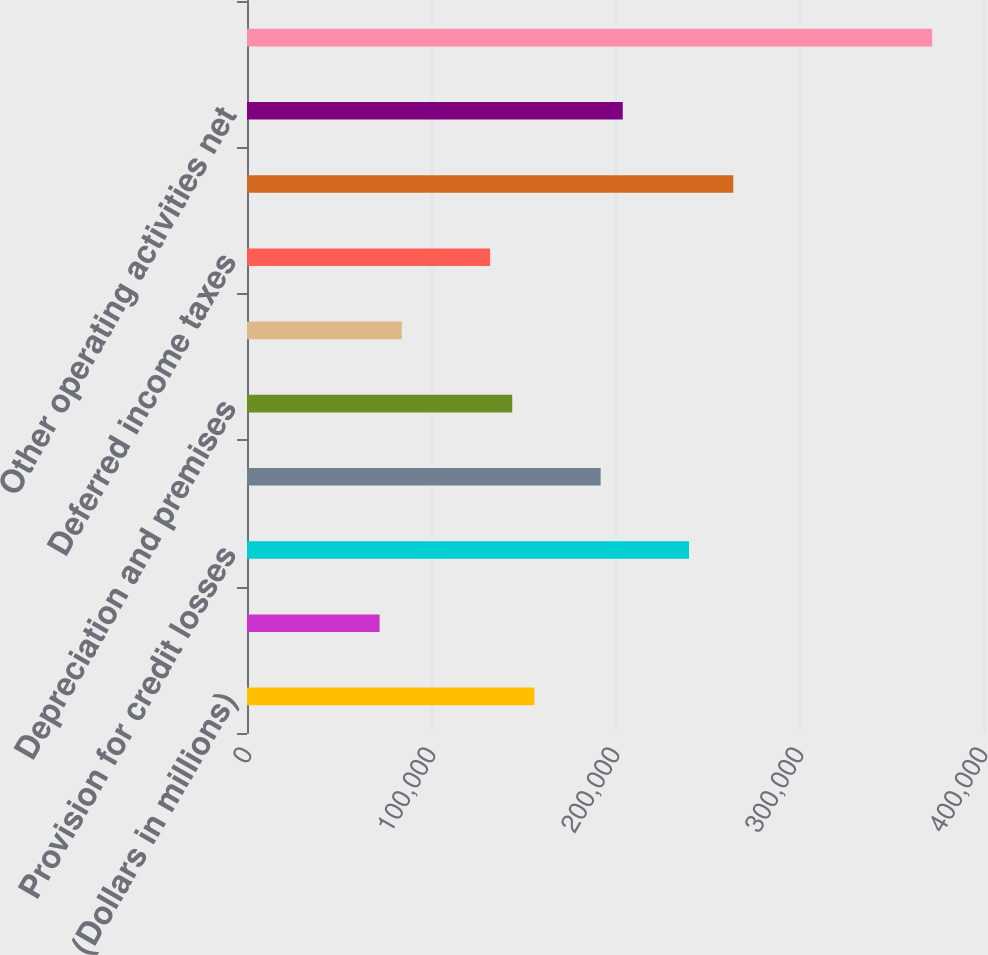Convert chart. <chart><loc_0><loc_0><loc_500><loc_500><bar_chart><fcel>(Dollars in millions)<fcel>Net income (loss)<fcel>Provision for credit losses<fcel>Gains on sales of debt<fcel>Depreciation and premises<fcel>Amortization of intangibles<fcel>Deferred income taxes<fcel>Net increase (decrease) in<fcel>Other operating activities net<fcel>Net cash provided by operating<nl><fcel>156162<fcel>72076.2<fcel>240247<fcel>192198<fcel>144149<fcel>84088.4<fcel>132137<fcel>264271<fcel>204210<fcel>372381<nl></chart> 